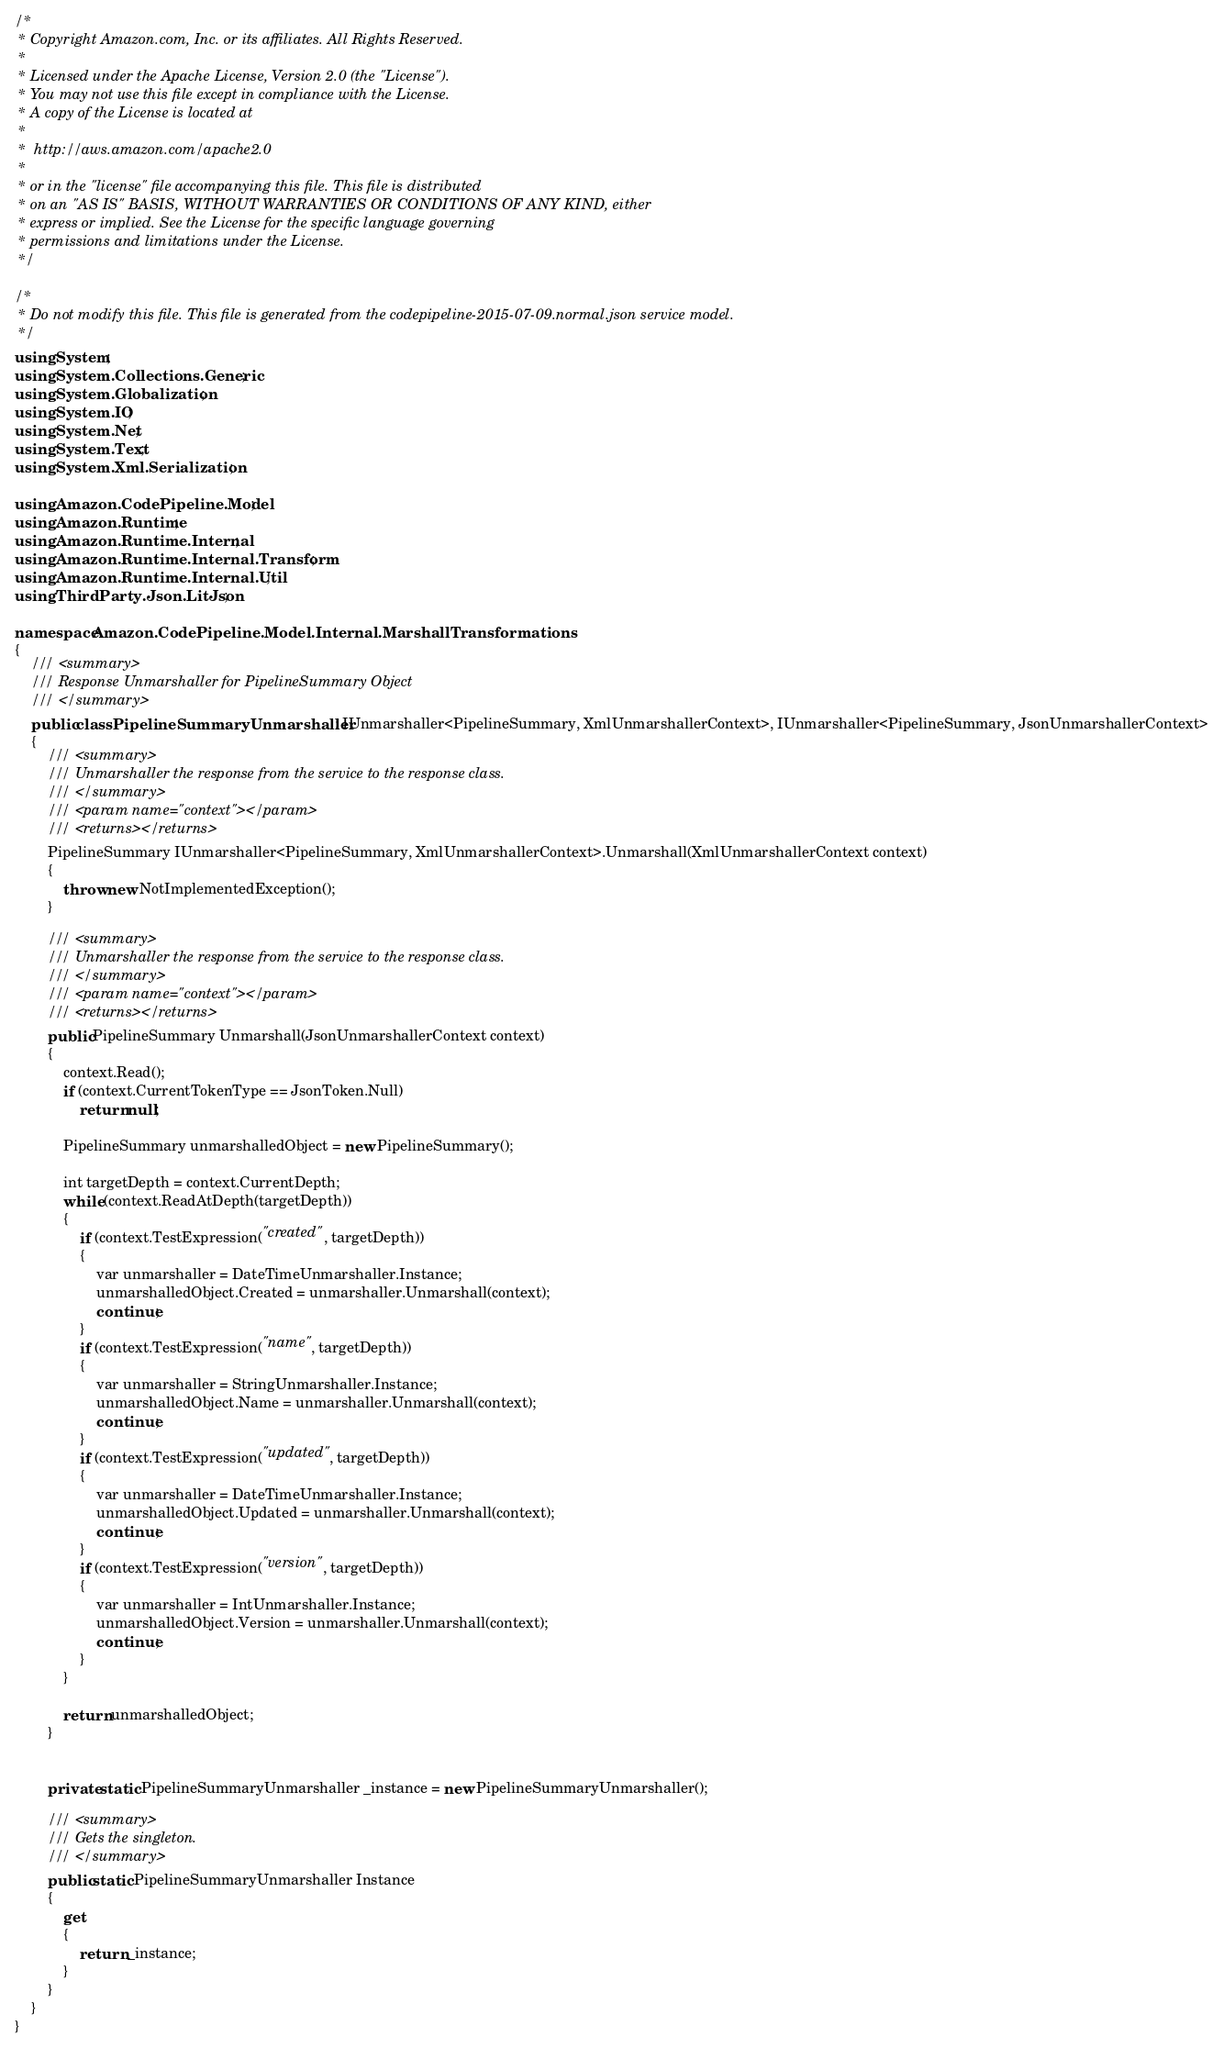Convert code to text. <code><loc_0><loc_0><loc_500><loc_500><_C#_>/*
 * Copyright Amazon.com, Inc. or its affiliates. All Rights Reserved.
 * 
 * Licensed under the Apache License, Version 2.0 (the "License").
 * You may not use this file except in compliance with the License.
 * A copy of the License is located at
 * 
 *  http://aws.amazon.com/apache2.0
 * 
 * or in the "license" file accompanying this file. This file is distributed
 * on an "AS IS" BASIS, WITHOUT WARRANTIES OR CONDITIONS OF ANY KIND, either
 * express or implied. See the License for the specific language governing
 * permissions and limitations under the License.
 */

/*
 * Do not modify this file. This file is generated from the codepipeline-2015-07-09.normal.json service model.
 */
using System;
using System.Collections.Generic;
using System.Globalization;
using System.IO;
using System.Net;
using System.Text;
using System.Xml.Serialization;

using Amazon.CodePipeline.Model;
using Amazon.Runtime;
using Amazon.Runtime.Internal;
using Amazon.Runtime.Internal.Transform;
using Amazon.Runtime.Internal.Util;
using ThirdParty.Json.LitJson;

namespace Amazon.CodePipeline.Model.Internal.MarshallTransformations
{
    /// <summary>
    /// Response Unmarshaller for PipelineSummary Object
    /// </summary>  
    public class PipelineSummaryUnmarshaller : IUnmarshaller<PipelineSummary, XmlUnmarshallerContext>, IUnmarshaller<PipelineSummary, JsonUnmarshallerContext>
    {
        /// <summary>
        /// Unmarshaller the response from the service to the response class.
        /// </summary>  
        /// <param name="context"></param>
        /// <returns></returns>
        PipelineSummary IUnmarshaller<PipelineSummary, XmlUnmarshallerContext>.Unmarshall(XmlUnmarshallerContext context)
        {
            throw new NotImplementedException();
        }

        /// <summary>
        /// Unmarshaller the response from the service to the response class.
        /// </summary>  
        /// <param name="context"></param>
        /// <returns></returns>
        public PipelineSummary Unmarshall(JsonUnmarshallerContext context)
        {
            context.Read();
            if (context.CurrentTokenType == JsonToken.Null) 
                return null;

            PipelineSummary unmarshalledObject = new PipelineSummary();
        
            int targetDepth = context.CurrentDepth;
            while (context.ReadAtDepth(targetDepth))
            {
                if (context.TestExpression("created", targetDepth))
                {
                    var unmarshaller = DateTimeUnmarshaller.Instance;
                    unmarshalledObject.Created = unmarshaller.Unmarshall(context);
                    continue;
                }
                if (context.TestExpression("name", targetDepth))
                {
                    var unmarshaller = StringUnmarshaller.Instance;
                    unmarshalledObject.Name = unmarshaller.Unmarshall(context);
                    continue;
                }
                if (context.TestExpression("updated", targetDepth))
                {
                    var unmarshaller = DateTimeUnmarshaller.Instance;
                    unmarshalledObject.Updated = unmarshaller.Unmarshall(context);
                    continue;
                }
                if (context.TestExpression("version", targetDepth))
                {
                    var unmarshaller = IntUnmarshaller.Instance;
                    unmarshalledObject.Version = unmarshaller.Unmarshall(context);
                    continue;
                }
            }
          
            return unmarshalledObject;
        }


        private static PipelineSummaryUnmarshaller _instance = new PipelineSummaryUnmarshaller();        

        /// <summary>
        /// Gets the singleton.
        /// </summary>  
        public static PipelineSummaryUnmarshaller Instance
        {
            get
            {
                return _instance;
            }
        }
    }
}</code> 